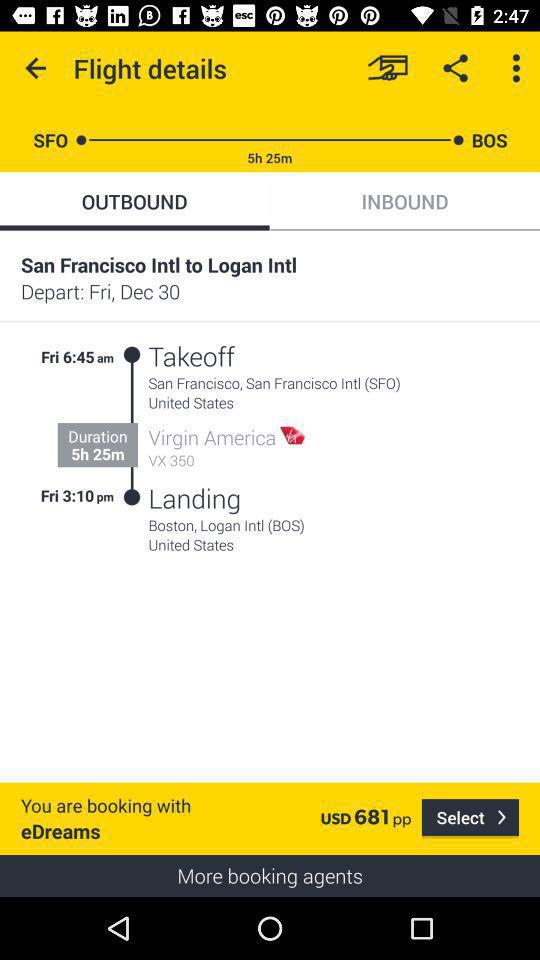What is the name of the departure point? The departure point is "San Francisco Intl". 